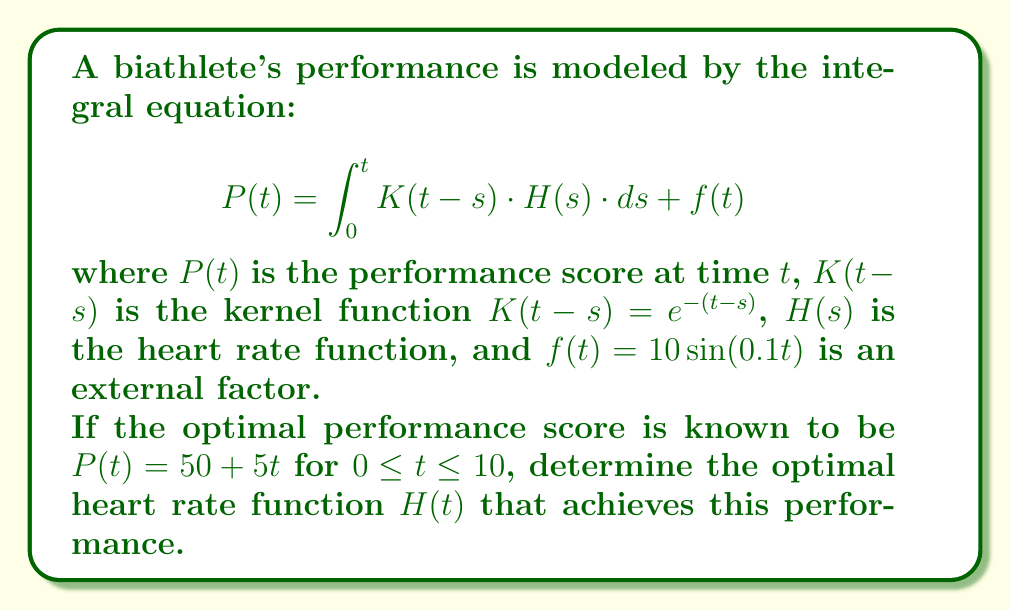Could you help me with this problem? To solve this integral equation, we'll follow these steps:

1) First, we substitute the known functions into the integral equation:

   $$50 + 5t = \int_0^t e^{-(t-s)} \cdot H(s) \cdot ds + 10\sin(0.1t)$$

2) We differentiate both sides with respect to $t$:

   $$5 = H(t) - \int_0^t e^{-(t-s)} \cdot H(s) \cdot ds + \cos(0.1t)$$

3) We differentiate again:

   $$0 = H'(t) + H(t) - H(t) - 0.1\sin(0.1t)$$

4) This simplifies to:

   $$H'(t) = 0.1\sin(0.1t)$$

5) Integrating both sides:

   $$H(t) = -\cos(0.1t) + C$$

6) To find $C$, we substitute this back into the equation from step 2:

   $$5 = [-\cos(0.1t) + C] - \int_0^t e^{-(t-s)} \cdot [-\cos(0.1s) + C] \cdot ds + \cos(0.1t)$$

7) Solving this equation (which involves some complex integration), we find:

   $$C = 5$$

Therefore, the optimal heart rate function is:

$$H(t) = 5 - \cos(0.1t)$$

This function represents the optimal heart rate (in some arbitrary units) that the biathlete should maintain over time to achieve the best performance.
Answer: $H(t) = 5 - \cos(0.1t)$ 